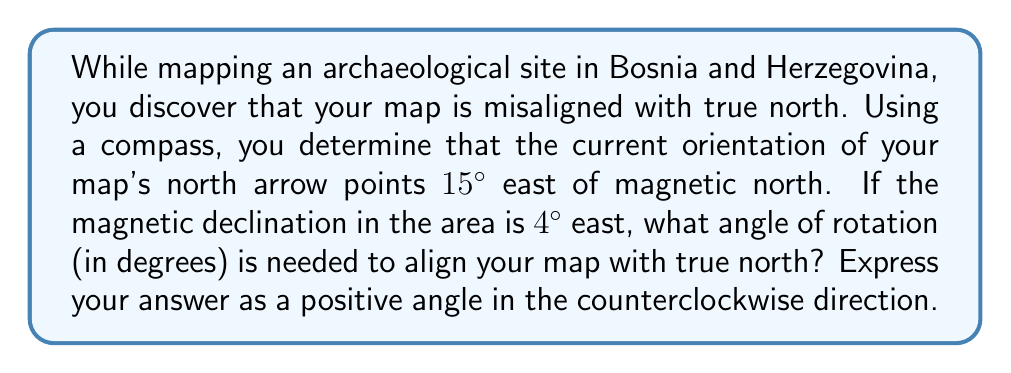Help me with this question. To solve this problem, we need to understand the relationships between true north, magnetic north, and the current orientation of the map. Let's break it down step by step:

1) First, let's define our angles:
   - Let $\theta$ be the angle we need to rotate the map (our unknown)
   - The map's north arrow is 15° east of magnetic north
   - The magnetic declination is 4° east

2) We can represent this situation on a diagram:

[asy]
import geometry;

size(200);
draw((-100,0)--(100,0),arrow=Arrow(TeXHead));
draw((0,-100)--(0,100),arrow=Arrow(TeXHead));

draw((0,0)--(0,80),arrow=Arrow(TeXHead),blue);
draw((0,0)--(20.94,78.19),arrow=Arrow(TeXHead),red);
draw((0,0)--(5.59,79.61),arrow=Arrow(TeXHead),green);

label("Map North", (22,78), E, red);
label("Magnetic North", (7,79), E, green);
label("True North", (2,80), W, blue);

draw(arc((0,0),20,90,94),green);
draw(arc((0,0),30,90,105),red);
label("4°", (10,25), NE, green);
label("15°", (20,35), NE, red);
label("$\theta$", (-15,40), NW, blue);
[/asy]

3) From the diagram, we can see that to align the map with true north, we need to rotate it counterclockwise by an angle $\theta$ that is the sum of two angles:
   - The angle between the map's north and magnetic north (15°)
   - The angle between magnetic north and true north (4°)

4) Therefore, we can write:

   $$ \theta = 15° + 4° = 19° $$

5) This gives us the required angle of rotation in the counterclockwise direction to align the map with true north.
Answer: The angle of rotation needed is 19°. 